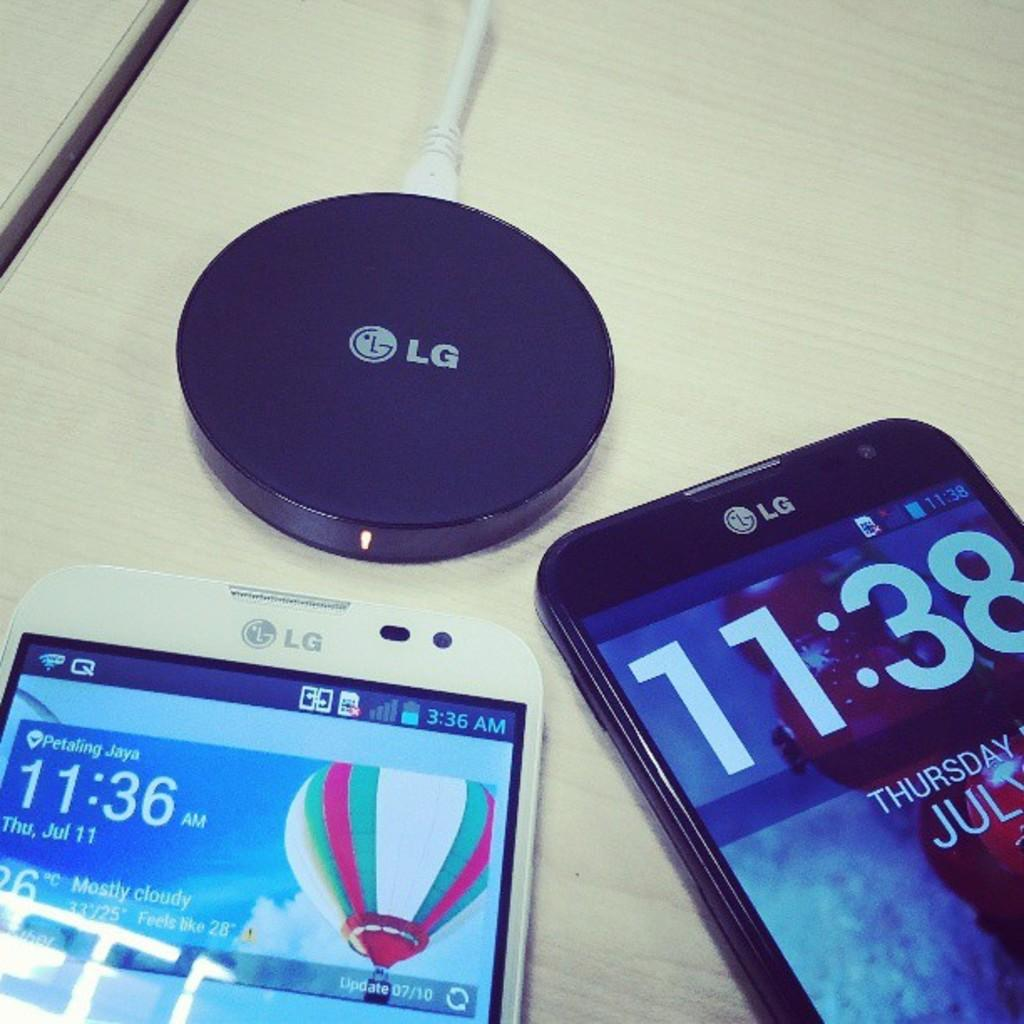<image>
Give a short and clear explanation of the subsequent image. Two phones on a table next to an LG Battery. 